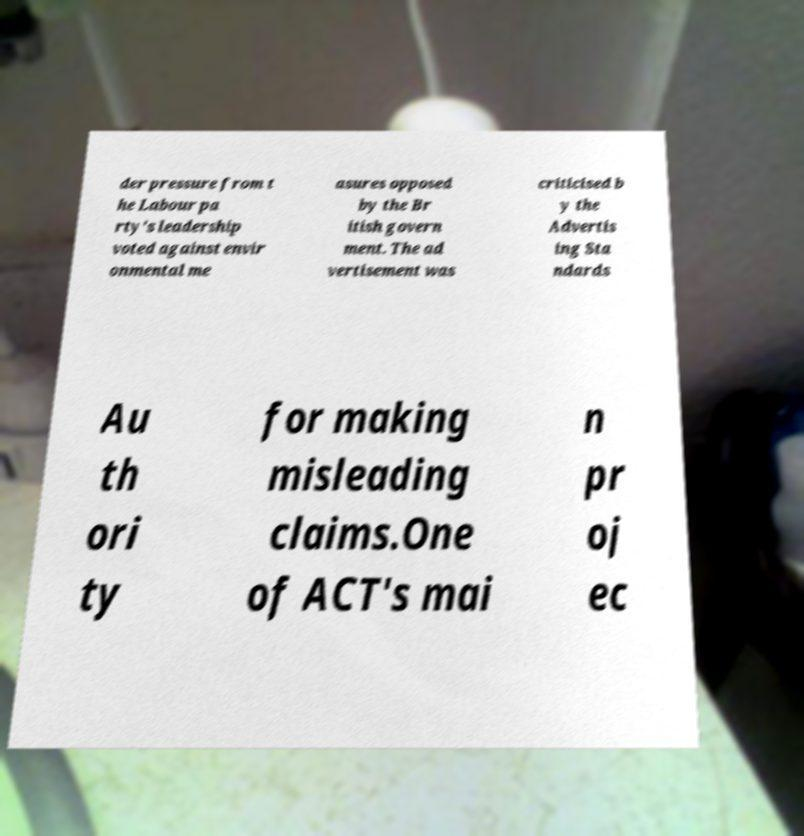For documentation purposes, I need the text within this image transcribed. Could you provide that? der pressure from t he Labour pa rty's leadership voted against envir onmental me asures opposed by the Br itish govern ment. The ad vertisement was criticised b y the Advertis ing Sta ndards Au th ori ty for making misleading claims.One of ACT's mai n pr oj ec 